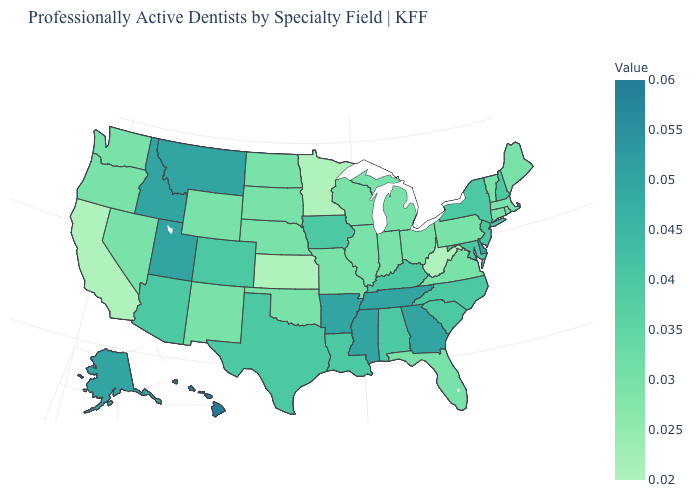Which states have the highest value in the USA?
Write a very short answer. Hawaii. Is the legend a continuous bar?
Quick response, please. Yes. Which states have the lowest value in the West?
Quick response, please. California. Does Maine have the highest value in the Northeast?
Be succinct. No. 